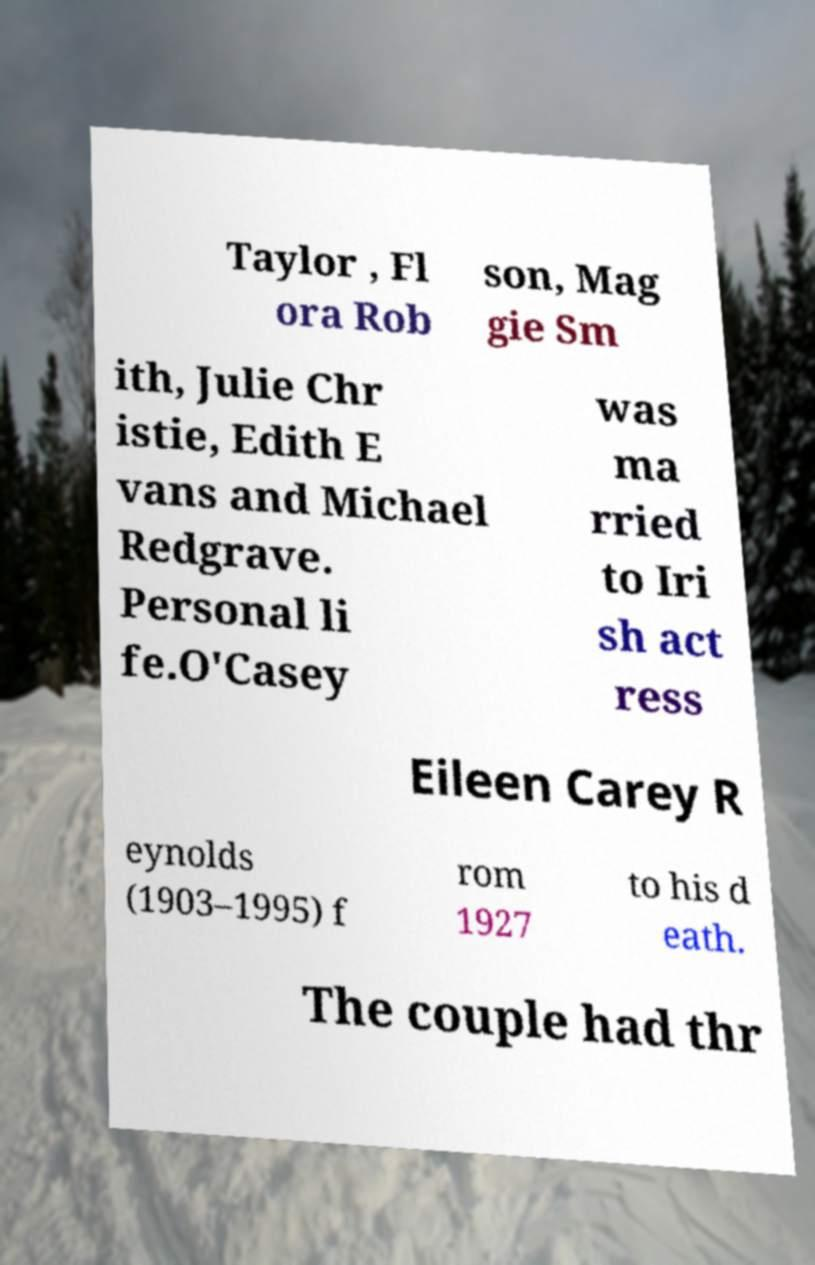Could you extract and type out the text from this image? Taylor , Fl ora Rob son, Mag gie Sm ith, Julie Chr istie, Edith E vans and Michael Redgrave. Personal li fe.O'Casey was ma rried to Iri sh act ress Eileen Carey R eynolds (1903–1995) f rom 1927 to his d eath. The couple had thr 